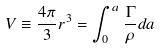<formula> <loc_0><loc_0><loc_500><loc_500>V \equiv \frac { 4 \pi } { 3 } r ^ { 3 } = \int _ { 0 } ^ { a } \frac { \Gamma } { \rho } d a</formula> 